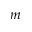Convert formula to latex. <formula><loc_0><loc_0><loc_500><loc_500>m</formula> 